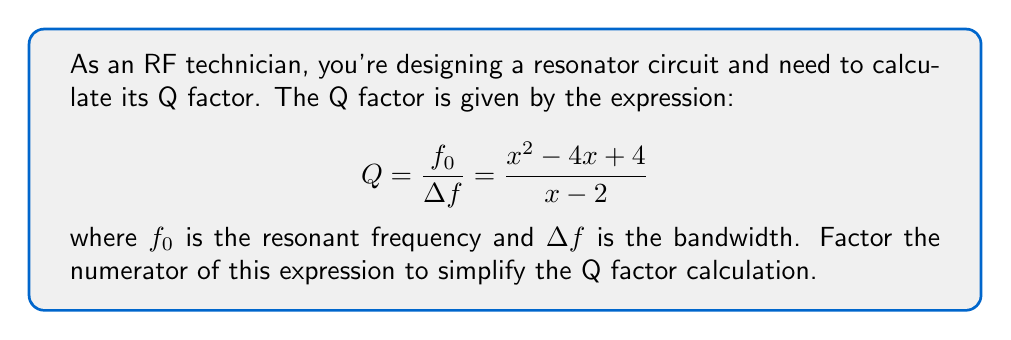Show me your answer to this math problem. To factor the numerator of the Q factor expression, we'll follow these steps:

1) First, identify the polynomial in the numerator:
   $x^2 - 4x + 4$

2) This is a quadratic expression in the form $ax^2 + bx + c$, where:
   $a = 1$, $b = -4$, and $c = 4$

3) To factor this, we'll use the method of finding two numbers that multiply to give $ac$ and add to give $b$. In this case, we need two numbers that:
   - Multiply to give: $a * c = 1 * 4 = 4$
   - Add to give: $b = -4$

4) The numbers that satisfy these conditions are $-2$ and $-2$

5) We can rewrite the middle term using these numbers:
   $x^2 - 2x - 2x + 4$

6) Now we can factor by grouping:
   $(x^2 - 2x) + (-2x + 4)$
   $x(x - 2) - 2(x - 2)$
   $(x - 2)(x - 2)$

7) This can be written as a perfect square:
   $(x - 2)^2$

Therefore, the factored numerator is $(x - 2)^2$.

8) The Q factor expression can now be written as:

$$ Q = \frac{(x - 2)^2}{x - 2} $$

9) The $(x - 2)$ term cancels out in the numerator and denominator, leaving:

$$ Q = x - 2 $$

This simplified form makes the Q factor calculation much easier for the RF technician.
Answer: $Q = x - 2$ 